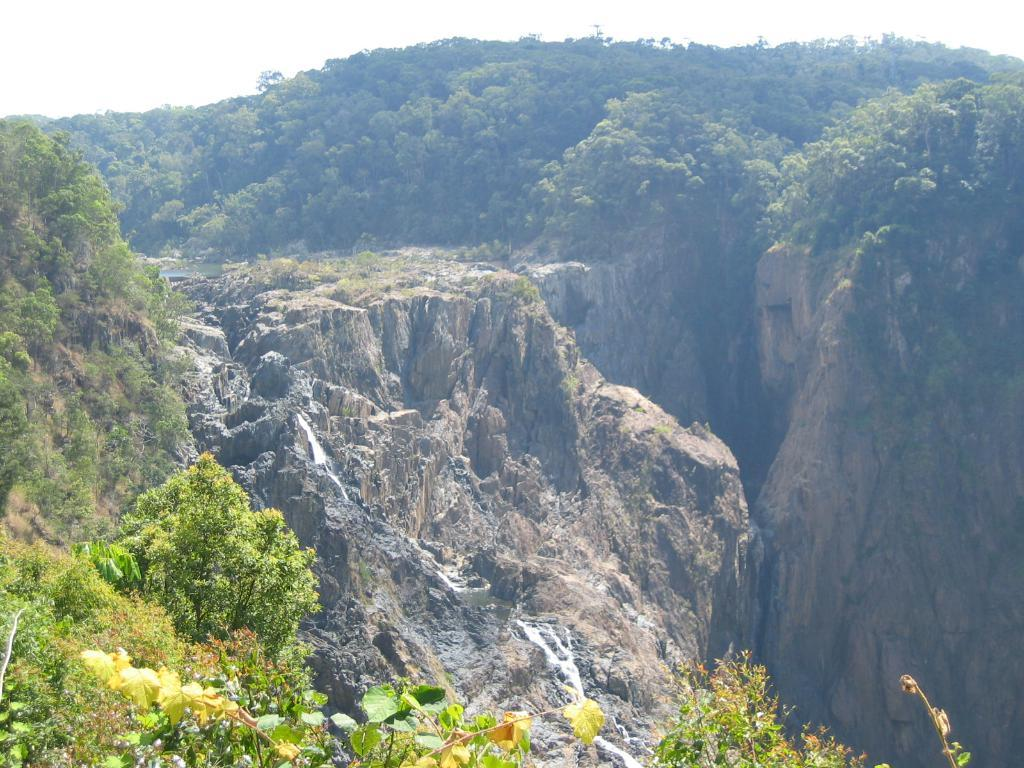What natural feature can be seen on the mountain in the image? There are trees on the mountain in the image. What is coming down from the mountain? There is a waterfall coming down from the mountain in the image. What can be seen in the distance behind the mountain? There are other mountains in the background of the image. What is visible in the sky in the image? There are clouds in the sky in the image. Can you see any volleyball courts in the image? There are no volleyball courts present in the image. How does the waste management system work on the mountain in the image? There is no information about waste management in the image, as it focuses on natural features such as trees, waterfalls, and mountains. 